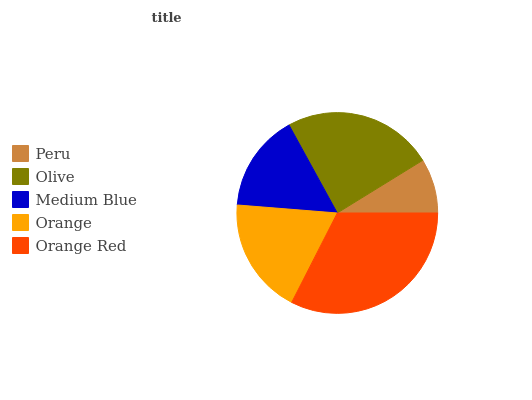Is Peru the minimum?
Answer yes or no. Yes. Is Orange Red the maximum?
Answer yes or no. Yes. Is Olive the minimum?
Answer yes or no. No. Is Olive the maximum?
Answer yes or no. No. Is Olive greater than Peru?
Answer yes or no. Yes. Is Peru less than Olive?
Answer yes or no. Yes. Is Peru greater than Olive?
Answer yes or no. No. Is Olive less than Peru?
Answer yes or no. No. Is Orange the high median?
Answer yes or no. Yes. Is Orange the low median?
Answer yes or no. Yes. Is Medium Blue the high median?
Answer yes or no. No. Is Orange Red the low median?
Answer yes or no. No. 